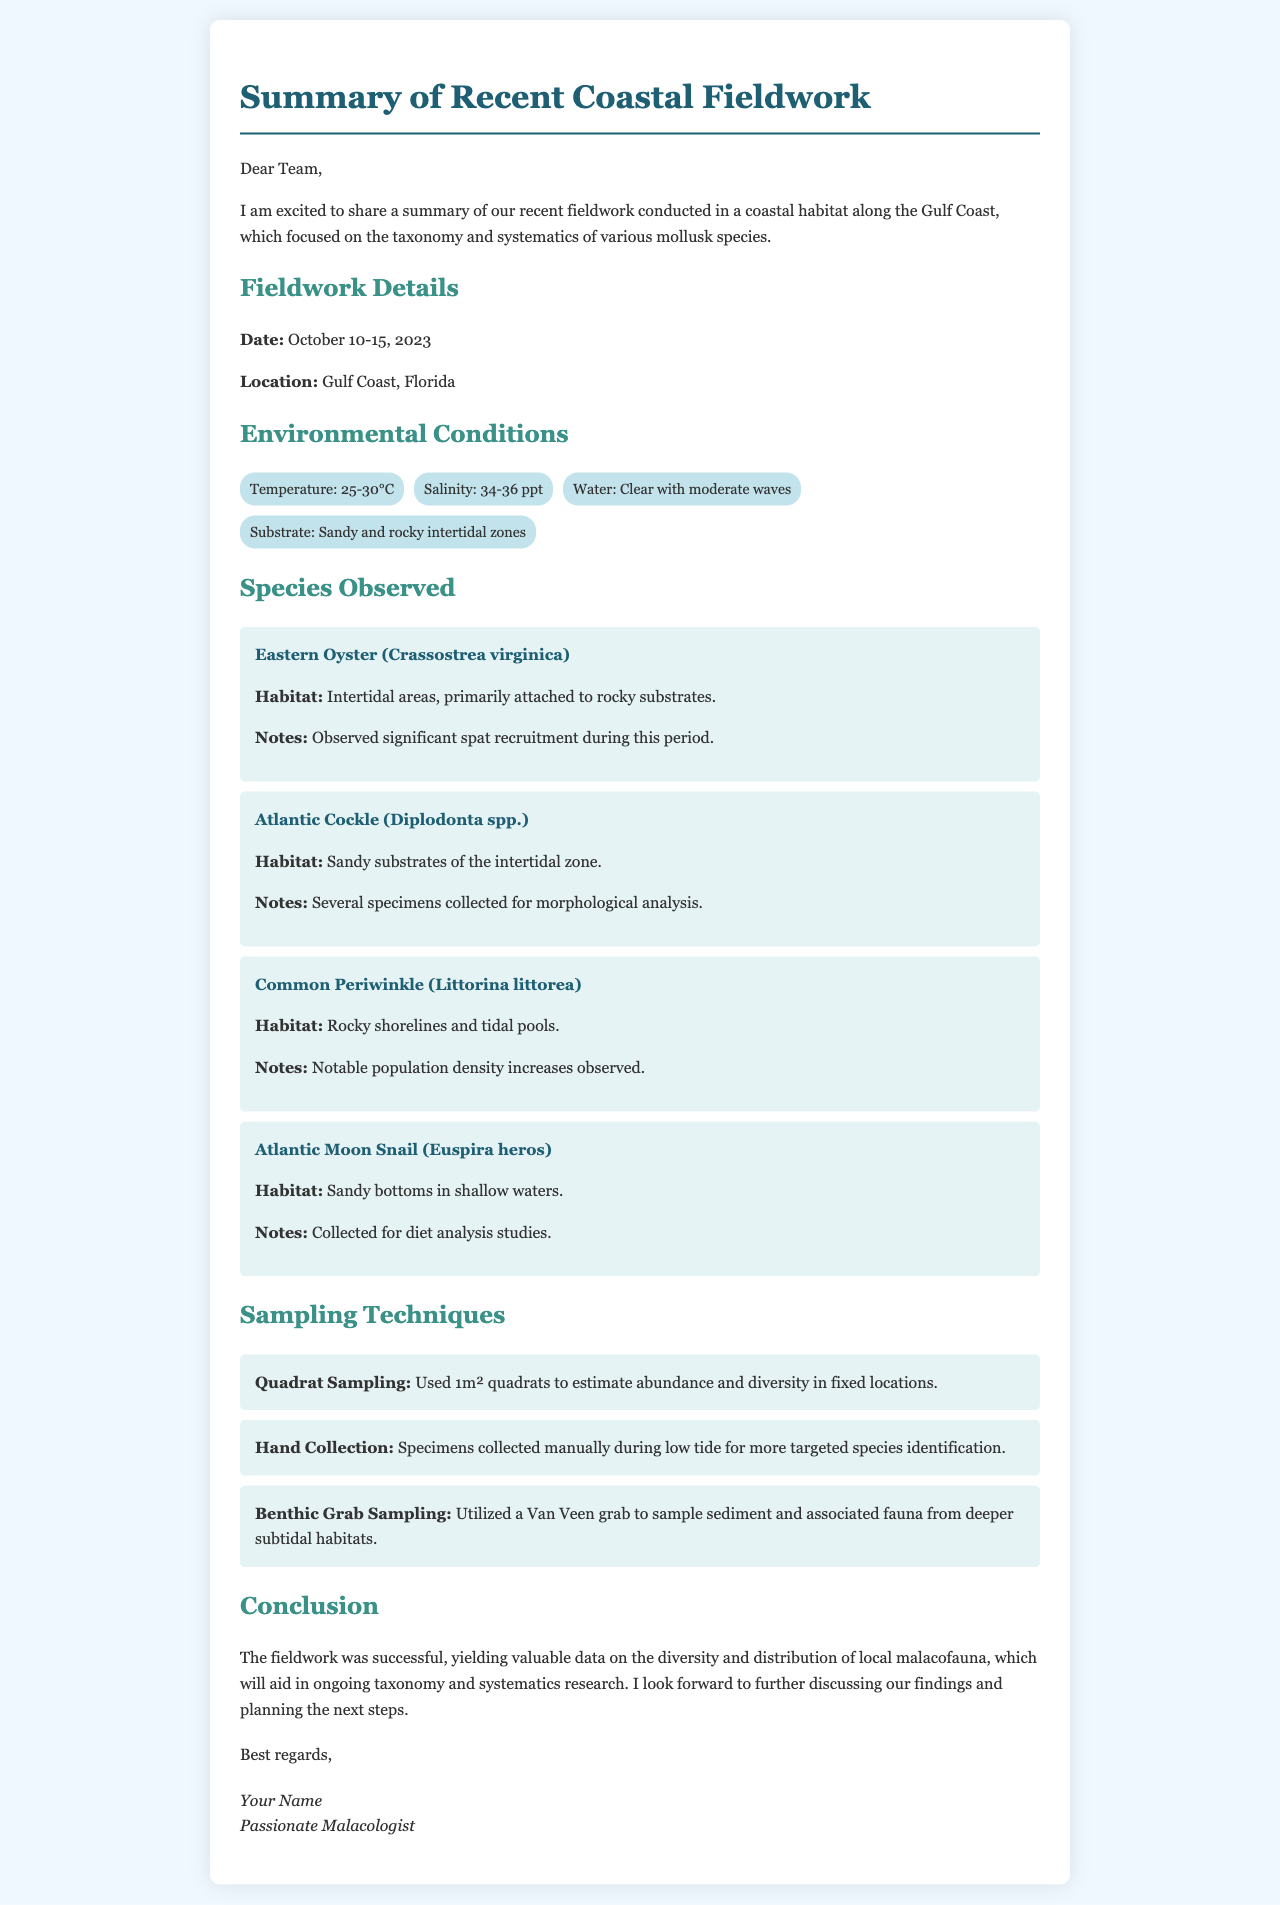What is the date of the fieldwork? The date is specified in the document, indicating when the fieldwork occurred.
Answer: October 10-15, 2023 Where was the fieldwork conducted? The document states the specific location of the fieldwork.
Answer: Gulf Coast, Florida What is the habitat of the Eastern Oyster? The habitat details are provided for the species observed during the fieldwork.
Answer: Intertidal areas, primarily attached to rocky substrates Which sampling technique was used for estimating abundance and diversity? The document lists the techniques employed during the fieldwork, including the one for estimating abundance and diversity.
Answer: Quadrat Sampling How many species were observed in the fieldwork? The number of species mentioned in the document indicates the diversity recorded during the fieldwork.
Answer: Four species What environmental condition had a temperature of 25-30°C? This condition is one of the specific environmental factors mentioned in the report.
Answer: Temperature Why were Atlantic Cockle specimens collected? The document notes the purpose behind collecting specimens of specific species.
Answer: Morphological analysis What does the conclusion state about the fieldwork? The conclusion summarizes the results and implications of the fieldwork as detailed in the document.
Answer: Successful, yielding valuable data on the diversity and distribution of local malacofauna 